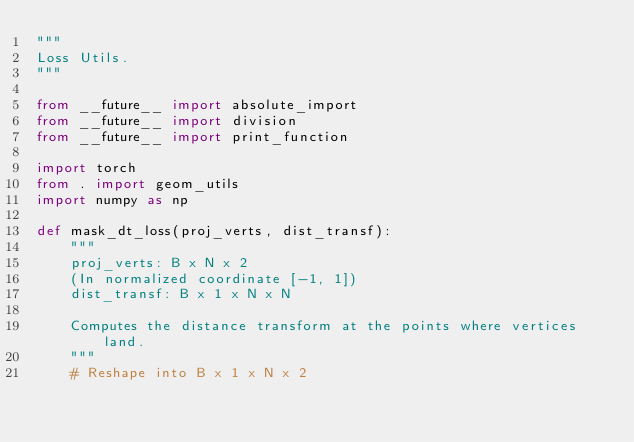<code> <loc_0><loc_0><loc_500><loc_500><_Python_>"""
Loss Utils.
"""

from __future__ import absolute_import
from __future__ import division
from __future__ import print_function

import torch
from . import geom_utils
import numpy as np

def mask_dt_loss(proj_verts, dist_transf):
    """
    proj_verts: B x N x 2
    (In normalized coordinate [-1, 1])
    dist_transf: B x 1 x N x N

    Computes the distance transform at the points where vertices land.
    """
    # Reshape into B x 1 x N x 2</code> 